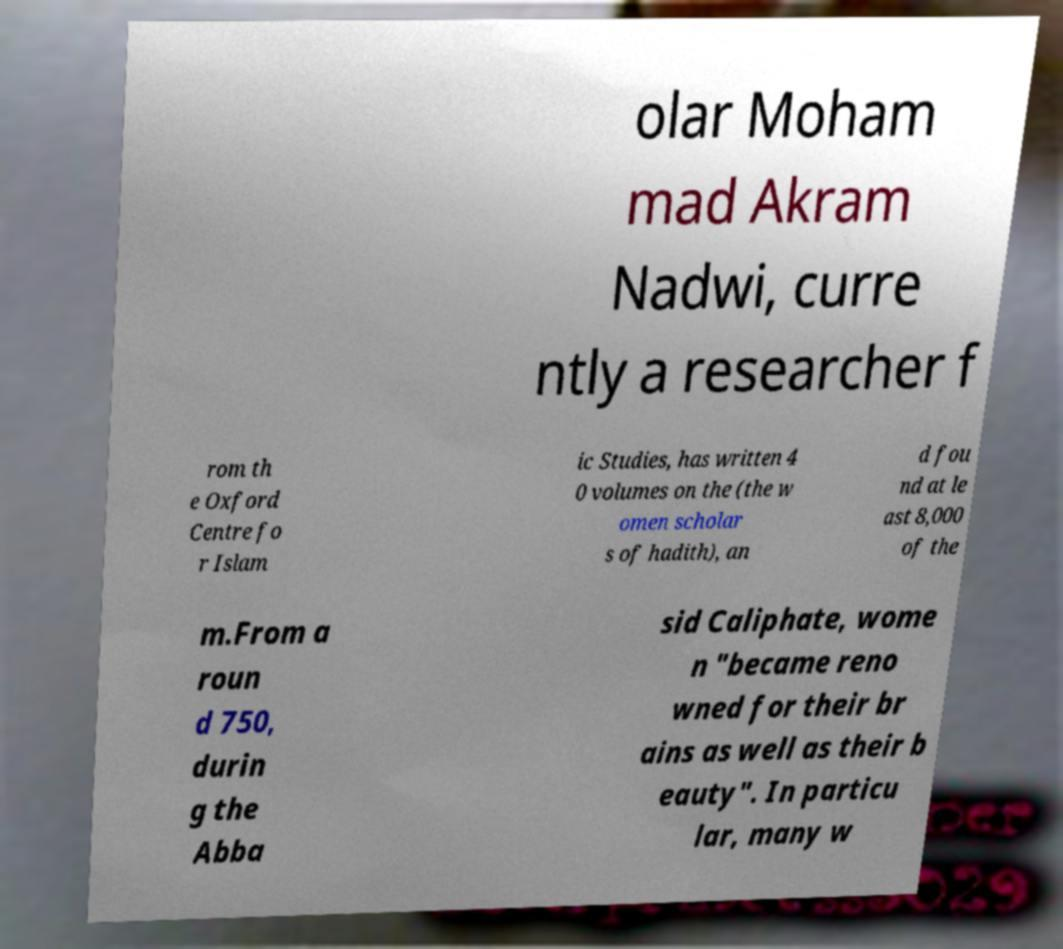Could you assist in decoding the text presented in this image and type it out clearly? olar Moham mad Akram Nadwi, curre ntly a researcher f rom th e Oxford Centre fo r Islam ic Studies, has written 4 0 volumes on the (the w omen scholar s of hadith), an d fou nd at le ast 8,000 of the m.From a roun d 750, durin g the Abba sid Caliphate, wome n "became reno wned for their br ains as well as their b eauty". In particu lar, many w 